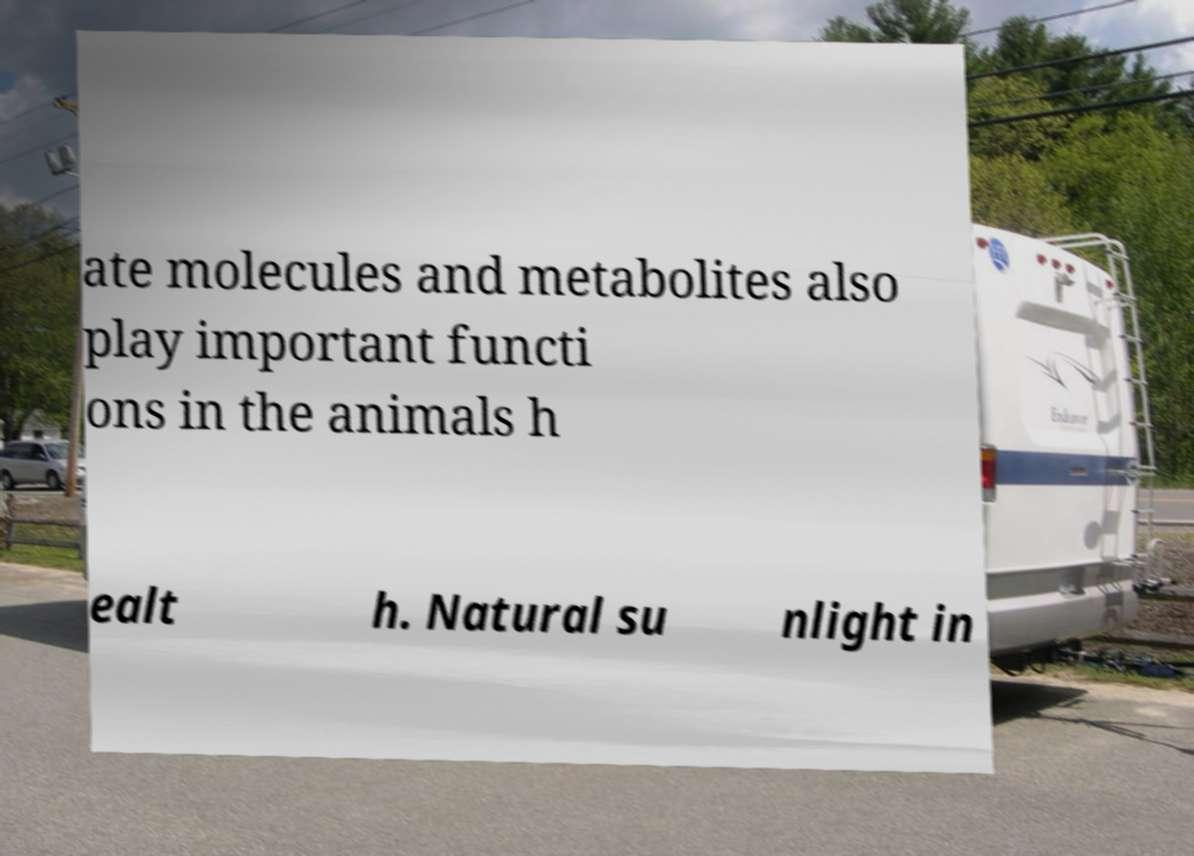Can you read and provide the text displayed in the image?This photo seems to have some interesting text. Can you extract and type it out for me? ate molecules and metabolites also play important functi ons in the animals h ealt h. Natural su nlight in 